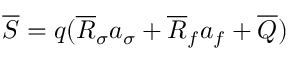<formula> <loc_0><loc_0><loc_500><loc_500>\overline { S } = q ( \overline { R } _ { \sigma } a _ { \sigma } + \overline { R } _ { f } a _ { f } + \overline { Q } )</formula> 